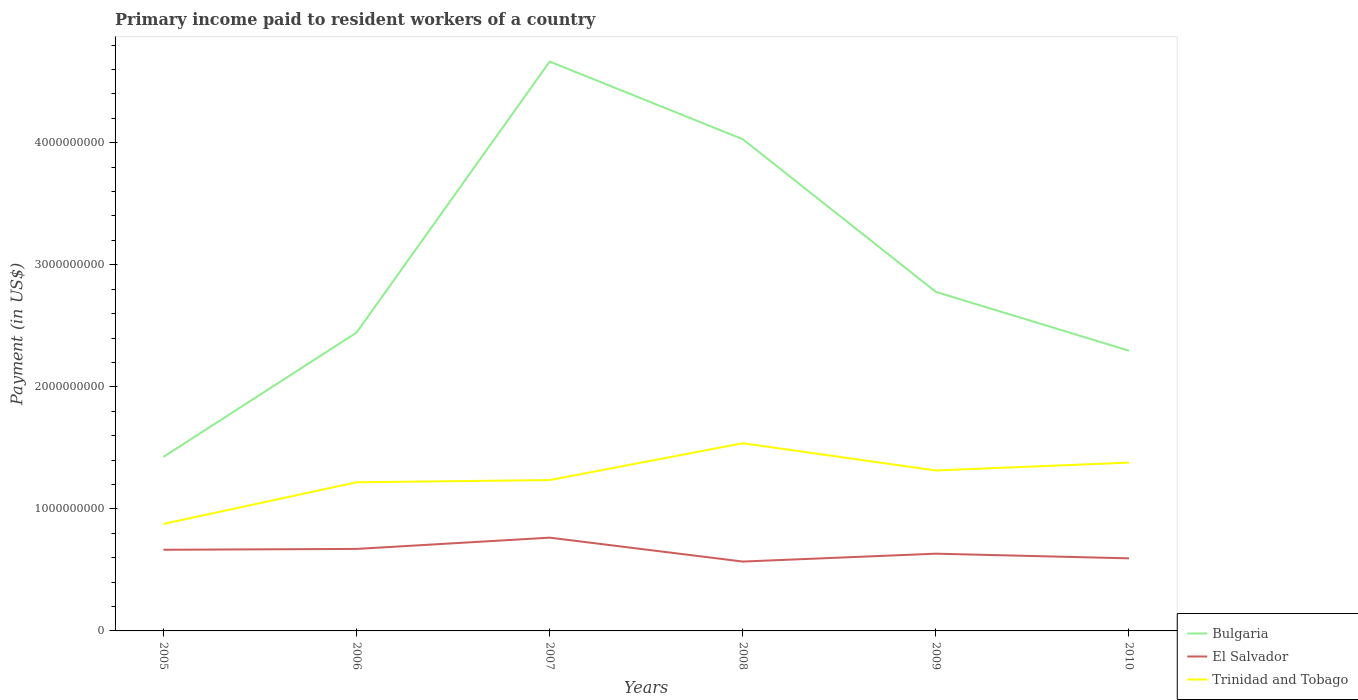Is the number of lines equal to the number of legend labels?
Provide a short and direct response. Yes. Across all years, what is the maximum amount paid to workers in Bulgaria?
Your answer should be compact. 1.43e+09. In which year was the amount paid to workers in El Salvador maximum?
Offer a very short reply. 2008. What is the total amount paid to workers in Trinidad and Tobago in the graph?
Your answer should be very brief. -1.61e+08. What is the difference between the highest and the second highest amount paid to workers in El Salvador?
Offer a very short reply. 1.96e+08. Is the amount paid to workers in Trinidad and Tobago strictly greater than the amount paid to workers in El Salvador over the years?
Make the answer very short. No. How many lines are there?
Offer a very short reply. 3. How many years are there in the graph?
Your response must be concise. 6. What is the difference between two consecutive major ticks on the Y-axis?
Make the answer very short. 1.00e+09. Are the values on the major ticks of Y-axis written in scientific E-notation?
Offer a very short reply. No. Does the graph contain any zero values?
Your answer should be compact. No. Where does the legend appear in the graph?
Your response must be concise. Bottom right. How are the legend labels stacked?
Your response must be concise. Vertical. What is the title of the graph?
Keep it short and to the point. Primary income paid to resident workers of a country. What is the label or title of the X-axis?
Provide a short and direct response. Years. What is the label or title of the Y-axis?
Make the answer very short. Payment (in US$). What is the Payment (in US$) of Bulgaria in 2005?
Offer a terse response. 1.43e+09. What is the Payment (in US$) of El Salvador in 2005?
Give a very brief answer. 6.65e+08. What is the Payment (in US$) of Trinidad and Tobago in 2005?
Provide a succinct answer. 8.77e+08. What is the Payment (in US$) of Bulgaria in 2006?
Ensure brevity in your answer.  2.44e+09. What is the Payment (in US$) of El Salvador in 2006?
Give a very brief answer. 6.72e+08. What is the Payment (in US$) of Trinidad and Tobago in 2006?
Keep it short and to the point. 1.22e+09. What is the Payment (in US$) in Bulgaria in 2007?
Make the answer very short. 4.67e+09. What is the Payment (in US$) of El Salvador in 2007?
Provide a short and direct response. 7.64e+08. What is the Payment (in US$) in Trinidad and Tobago in 2007?
Give a very brief answer. 1.24e+09. What is the Payment (in US$) of Bulgaria in 2008?
Offer a terse response. 4.03e+09. What is the Payment (in US$) in El Salvador in 2008?
Make the answer very short. 5.68e+08. What is the Payment (in US$) of Trinidad and Tobago in 2008?
Your answer should be compact. 1.54e+09. What is the Payment (in US$) in Bulgaria in 2009?
Your answer should be very brief. 2.78e+09. What is the Payment (in US$) of El Salvador in 2009?
Offer a very short reply. 6.33e+08. What is the Payment (in US$) in Trinidad and Tobago in 2009?
Your answer should be compact. 1.31e+09. What is the Payment (in US$) in Bulgaria in 2010?
Your answer should be compact. 2.30e+09. What is the Payment (in US$) of El Salvador in 2010?
Give a very brief answer. 5.95e+08. What is the Payment (in US$) of Trinidad and Tobago in 2010?
Make the answer very short. 1.38e+09. Across all years, what is the maximum Payment (in US$) in Bulgaria?
Your response must be concise. 4.67e+09. Across all years, what is the maximum Payment (in US$) in El Salvador?
Make the answer very short. 7.64e+08. Across all years, what is the maximum Payment (in US$) in Trinidad and Tobago?
Your answer should be compact. 1.54e+09. Across all years, what is the minimum Payment (in US$) in Bulgaria?
Your answer should be compact. 1.43e+09. Across all years, what is the minimum Payment (in US$) of El Salvador?
Offer a very short reply. 5.68e+08. Across all years, what is the minimum Payment (in US$) in Trinidad and Tobago?
Provide a short and direct response. 8.77e+08. What is the total Payment (in US$) of Bulgaria in the graph?
Give a very brief answer. 1.76e+1. What is the total Payment (in US$) in El Salvador in the graph?
Provide a short and direct response. 3.90e+09. What is the total Payment (in US$) in Trinidad and Tobago in the graph?
Offer a terse response. 7.56e+09. What is the difference between the Payment (in US$) of Bulgaria in 2005 and that in 2006?
Ensure brevity in your answer.  -1.02e+09. What is the difference between the Payment (in US$) of El Salvador in 2005 and that in 2006?
Your response must be concise. -6.92e+06. What is the difference between the Payment (in US$) of Trinidad and Tobago in 2005 and that in 2006?
Your answer should be very brief. -3.41e+08. What is the difference between the Payment (in US$) of Bulgaria in 2005 and that in 2007?
Make the answer very short. -3.24e+09. What is the difference between the Payment (in US$) of El Salvador in 2005 and that in 2007?
Offer a terse response. -9.93e+07. What is the difference between the Payment (in US$) in Trinidad and Tobago in 2005 and that in 2007?
Ensure brevity in your answer.  -3.59e+08. What is the difference between the Payment (in US$) of Bulgaria in 2005 and that in 2008?
Provide a short and direct response. -2.60e+09. What is the difference between the Payment (in US$) of El Salvador in 2005 and that in 2008?
Provide a succinct answer. 9.67e+07. What is the difference between the Payment (in US$) in Trinidad and Tobago in 2005 and that in 2008?
Offer a terse response. -6.61e+08. What is the difference between the Payment (in US$) in Bulgaria in 2005 and that in 2009?
Provide a succinct answer. -1.35e+09. What is the difference between the Payment (in US$) in El Salvador in 2005 and that in 2009?
Offer a terse response. 3.21e+07. What is the difference between the Payment (in US$) of Trinidad and Tobago in 2005 and that in 2009?
Your answer should be compact. -4.38e+08. What is the difference between the Payment (in US$) in Bulgaria in 2005 and that in 2010?
Give a very brief answer. -8.70e+08. What is the difference between the Payment (in US$) of El Salvador in 2005 and that in 2010?
Ensure brevity in your answer.  7.03e+07. What is the difference between the Payment (in US$) in Trinidad and Tobago in 2005 and that in 2010?
Provide a short and direct response. -5.02e+08. What is the difference between the Payment (in US$) in Bulgaria in 2006 and that in 2007?
Provide a short and direct response. -2.22e+09. What is the difference between the Payment (in US$) in El Salvador in 2006 and that in 2007?
Offer a terse response. -9.24e+07. What is the difference between the Payment (in US$) in Trinidad and Tobago in 2006 and that in 2007?
Your answer should be very brief. -1.78e+07. What is the difference between the Payment (in US$) in Bulgaria in 2006 and that in 2008?
Your response must be concise. -1.58e+09. What is the difference between the Payment (in US$) in El Salvador in 2006 and that in 2008?
Ensure brevity in your answer.  1.04e+08. What is the difference between the Payment (in US$) in Trinidad and Tobago in 2006 and that in 2008?
Make the answer very short. -3.20e+08. What is the difference between the Payment (in US$) of Bulgaria in 2006 and that in 2009?
Make the answer very short. -3.33e+08. What is the difference between the Payment (in US$) in El Salvador in 2006 and that in 2009?
Offer a very short reply. 3.90e+07. What is the difference between the Payment (in US$) in Trinidad and Tobago in 2006 and that in 2009?
Your response must be concise. -9.66e+07. What is the difference between the Payment (in US$) of Bulgaria in 2006 and that in 2010?
Make the answer very short. 1.49e+08. What is the difference between the Payment (in US$) in El Salvador in 2006 and that in 2010?
Ensure brevity in your answer.  7.72e+07. What is the difference between the Payment (in US$) of Trinidad and Tobago in 2006 and that in 2010?
Ensure brevity in your answer.  -1.61e+08. What is the difference between the Payment (in US$) of Bulgaria in 2007 and that in 2008?
Your answer should be very brief. 6.36e+08. What is the difference between the Payment (in US$) of El Salvador in 2007 and that in 2008?
Give a very brief answer. 1.96e+08. What is the difference between the Payment (in US$) of Trinidad and Tobago in 2007 and that in 2008?
Offer a very short reply. -3.02e+08. What is the difference between the Payment (in US$) in Bulgaria in 2007 and that in 2009?
Ensure brevity in your answer.  1.89e+09. What is the difference between the Payment (in US$) of El Salvador in 2007 and that in 2009?
Your answer should be compact. 1.31e+08. What is the difference between the Payment (in US$) in Trinidad and Tobago in 2007 and that in 2009?
Offer a very short reply. -7.88e+07. What is the difference between the Payment (in US$) in Bulgaria in 2007 and that in 2010?
Keep it short and to the point. 2.37e+09. What is the difference between the Payment (in US$) of El Salvador in 2007 and that in 2010?
Offer a terse response. 1.70e+08. What is the difference between the Payment (in US$) in Trinidad and Tobago in 2007 and that in 2010?
Provide a succinct answer. -1.43e+08. What is the difference between the Payment (in US$) in Bulgaria in 2008 and that in 2009?
Keep it short and to the point. 1.25e+09. What is the difference between the Payment (in US$) of El Salvador in 2008 and that in 2009?
Make the answer very short. -6.46e+07. What is the difference between the Payment (in US$) in Trinidad and Tobago in 2008 and that in 2009?
Your answer should be very brief. 2.23e+08. What is the difference between the Payment (in US$) of Bulgaria in 2008 and that in 2010?
Provide a short and direct response. 1.73e+09. What is the difference between the Payment (in US$) in El Salvador in 2008 and that in 2010?
Offer a very short reply. -2.64e+07. What is the difference between the Payment (in US$) in Trinidad and Tobago in 2008 and that in 2010?
Offer a terse response. 1.59e+08. What is the difference between the Payment (in US$) in Bulgaria in 2009 and that in 2010?
Ensure brevity in your answer.  4.82e+08. What is the difference between the Payment (in US$) in El Salvador in 2009 and that in 2010?
Keep it short and to the point. 3.82e+07. What is the difference between the Payment (in US$) in Trinidad and Tobago in 2009 and that in 2010?
Provide a short and direct response. -6.45e+07. What is the difference between the Payment (in US$) in Bulgaria in 2005 and the Payment (in US$) in El Salvador in 2006?
Your answer should be very brief. 7.54e+08. What is the difference between the Payment (in US$) in Bulgaria in 2005 and the Payment (in US$) in Trinidad and Tobago in 2006?
Give a very brief answer. 2.08e+08. What is the difference between the Payment (in US$) of El Salvador in 2005 and the Payment (in US$) of Trinidad and Tobago in 2006?
Your answer should be compact. -5.53e+08. What is the difference between the Payment (in US$) in Bulgaria in 2005 and the Payment (in US$) in El Salvador in 2007?
Make the answer very short. 6.62e+08. What is the difference between the Payment (in US$) of Bulgaria in 2005 and the Payment (in US$) of Trinidad and Tobago in 2007?
Your answer should be compact. 1.90e+08. What is the difference between the Payment (in US$) in El Salvador in 2005 and the Payment (in US$) in Trinidad and Tobago in 2007?
Make the answer very short. -5.71e+08. What is the difference between the Payment (in US$) in Bulgaria in 2005 and the Payment (in US$) in El Salvador in 2008?
Your response must be concise. 8.58e+08. What is the difference between the Payment (in US$) of Bulgaria in 2005 and the Payment (in US$) of Trinidad and Tobago in 2008?
Offer a terse response. -1.12e+08. What is the difference between the Payment (in US$) of El Salvador in 2005 and the Payment (in US$) of Trinidad and Tobago in 2008?
Give a very brief answer. -8.73e+08. What is the difference between the Payment (in US$) of Bulgaria in 2005 and the Payment (in US$) of El Salvador in 2009?
Keep it short and to the point. 7.93e+08. What is the difference between the Payment (in US$) in Bulgaria in 2005 and the Payment (in US$) in Trinidad and Tobago in 2009?
Provide a succinct answer. 1.11e+08. What is the difference between the Payment (in US$) of El Salvador in 2005 and the Payment (in US$) of Trinidad and Tobago in 2009?
Your answer should be very brief. -6.50e+08. What is the difference between the Payment (in US$) in Bulgaria in 2005 and the Payment (in US$) in El Salvador in 2010?
Provide a short and direct response. 8.31e+08. What is the difference between the Payment (in US$) in Bulgaria in 2005 and the Payment (in US$) in Trinidad and Tobago in 2010?
Give a very brief answer. 4.68e+07. What is the difference between the Payment (in US$) in El Salvador in 2005 and the Payment (in US$) in Trinidad and Tobago in 2010?
Provide a succinct answer. -7.14e+08. What is the difference between the Payment (in US$) of Bulgaria in 2006 and the Payment (in US$) of El Salvador in 2007?
Your answer should be compact. 1.68e+09. What is the difference between the Payment (in US$) in Bulgaria in 2006 and the Payment (in US$) in Trinidad and Tobago in 2007?
Offer a terse response. 1.21e+09. What is the difference between the Payment (in US$) of El Salvador in 2006 and the Payment (in US$) of Trinidad and Tobago in 2007?
Keep it short and to the point. -5.64e+08. What is the difference between the Payment (in US$) in Bulgaria in 2006 and the Payment (in US$) in El Salvador in 2008?
Keep it short and to the point. 1.88e+09. What is the difference between the Payment (in US$) of Bulgaria in 2006 and the Payment (in US$) of Trinidad and Tobago in 2008?
Your answer should be compact. 9.07e+08. What is the difference between the Payment (in US$) of El Salvador in 2006 and the Payment (in US$) of Trinidad and Tobago in 2008?
Keep it short and to the point. -8.66e+08. What is the difference between the Payment (in US$) in Bulgaria in 2006 and the Payment (in US$) in El Salvador in 2009?
Your answer should be very brief. 1.81e+09. What is the difference between the Payment (in US$) of Bulgaria in 2006 and the Payment (in US$) of Trinidad and Tobago in 2009?
Your answer should be very brief. 1.13e+09. What is the difference between the Payment (in US$) of El Salvador in 2006 and the Payment (in US$) of Trinidad and Tobago in 2009?
Ensure brevity in your answer.  -6.43e+08. What is the difference between the Payment (in US$) of Bulgaria in 2006 and the Payment (in US$) of El Salvador in 2010?
Give a very brief answer. 1.85e+09. What is the difference between the Payment (in US$) in Bulgaria in 2006 and the Payment (in US$) in Trinidad and Tobago in 2010?
Provide a short and direct response. 1.07e+09. What is the difference between the Payment (in US$) of El Salvador in 2006 and the Payment (in US$) of Trinidad and Tobago in 2010?
Give a very brief answer. -7.07e+08. What is the difference between the Payment (in US$) in Bulgaria in 2007 and the Payment (in US$) in El Salvador in 2008?
Keep it short and to the point. 4.10e+09. What is the difference between the Payment (in US$) of Bulgaria in 2007 and the Payment (in US$) of Trinidad and Tobago in 2008?
Give a very brief answer. 3.13e+09. What is the difference between the Payment (in US$) of El Salvador in 2007 and the Payment (in US$) of Trinidad and Tobago in 2008?
Your answer should be compact. -7.74e+08. What is the difference between the Payment (in US$) of Bulgaria in 2007 and the Payment (in US$) of El Salvador in 2009?
Provide a succinct answer. 4.03e+09. What is the difference between the Payment (in US$) in Bulgaria in 2007 and the Payment (in US$) in Trinidad and Tobago in 2009?
Provide a short and direct response. 3.35e+09. What is the difference between the Payment (in US$) of El Salvador in 2007 and the Payment (in US$) of Trinidad and Tobago in 2009?
Your answer should be compact. -5.50e+08. What is the difference between the Payment (in US$) in Bulgaria in 2007 and the Payment (in US$) in El Salvador in 2010?
Offer a very short reply. 4.07e+09. What is the difference between the Payment (in US$) of Bulgaria in 2007 and the Payment (in US$) of Trinidad and Tobago in 2010?
Make the answer very short. 3.29e+09. What is the difference between the Payment (in US$) in El Salvador in 2007 and the Payment (in US$) in Trinidad and Tobago in 2010?
Make the answer very short. -6.15e+08. What is the difference between the Payment (in US$) of Bulgaria in 2008 and the Payment (in US$) of El Salvador in 2009?
Give a very brief answer. 3.40e+09. What is the difference between the Payment (in US$) in Bulgaria in 2008 and the Payment (in US$) in Trinidad and Tobago in 2009?
Provide a short and direct response. 2.71e+09. What is the difference between the Payment (in US$) in El Salvador in 2008 and the Payment (in US$) in Trinidad and Tobago in 2009?
Offer a terse response. -7.46e+08. What is the difference between the Payment (in US$) of Bulgaria in 2008 and the Payment (in US$) of El Salvador in 2010?
Provide a succinct answer. 3.43e+09. What is the difference between the Payment (in US$) in Bulgaria in 2008 and the Payment (in US$) in Trinidad and Tobago in 2010?
Your answer should be compact. 2.65e+09. What is the difference between the Payment (in US$) of El Salvador in 2008 and the Payment (in US$) of Trinidad and Tobago in 2010?
Offer a very short reply. -8.11e+08. What is the difference between the Payment (in US$) in Bulgaria in 2009 and the Payment (in US$) in El Salvador in 2010?
Give a very brief answer. 2.18e+09. What is the difference between the Payment (in US$) of Bulgaria in 2009 and the Payment (in US$) of Trinidad and Tobago in 2010?
Ensure brevity in your answer.  1.40e+09. What is the difference between the Payment (in US$) in El Salvador in 2009 and the Payment (in US$) in Trinidad and Tobago in 2010?
Your answer should be very brief. -7.46e+08. What is the average Payment (in US$) in Bulgaria per year?
Offer a very short reply. 2.94e+09. What is the average Payment (in US$) of El Salvador per year?
Provide a succinct answer. 6.50e+08. What is the average Payment (in US$) in Trinidad and Tobago per year?
Give a very brief answer. 1.26e+09. In the year 2005, what is the difference between the Payment (in US$) in Bulgaria and Payment (in US$) in El Salvador?
Give a very brief answer. 7.61e+08. In the year 2005, what is the difference between the Payment (in US$) of Bulgaria and Payment (in US$) of Trinidad and Tobago?
Your answer should be very brief. 5.49e+08. In the year 2005, what is the difference between the Payment (in US$) of El Salvador and Payment (in US$) of Trinidad and Tobago?
Your answer should be very brief. -2.12e+08. In the year 2006, what is the difference between the Payment (in US$) in Bulgaria and Payment (in US$) in El Salvador?
Make the answer very short. 1.77e+09. In the year 2006, what is the difference between the Payment (in US$) in Bulgaria and Payment (in US$) in Trinidad and Tobago?
Give a very brief answer. 1.23e+09. In the year 2006, what is the difference between the Payment (in US$) of El Salvador and Payment (in US$) of Trinidad and Tobago?
Ensure brevity in your answer.  -5.46e+08. In the year 2007, what is the difference between the Payment (in US$) of Bulgaria and Payment (in US$) of El Salvador?
Provide a short and direct response. 3.90e+09. In the year 2007, what is the difference between the Payment (in US$) in Bulgaria and Payment (in US$) in Trinidad and Tobago?
Your answer should be compact. 3.43e+09. In the year 2007, what is the difference between the Payment (in US$) in El Salvador and Payment (in US$) in Trinidad and Tobago?
Offer a very short reply. -4.72e+08. In the year 2008, what is the difference between the Payment (in US$) of Bulgaria and Payment (in US$) of El Salvador?
Make the answer very short. 3.46e+09. In the year 2008, what is the difference between the Payment (in US$) of Bulgaria and Payment (in US$) of Trinidad and Tobago?
Your answer should be compact. 2.49e+09. In the year 2008, what is the difference between the Payment (in US$) in El Salvador and Payment (in US$) in Trinidad and Tobago?
Your response must be concise. -9.70e+08. In the year 2009, what is the difference between the Payment (in US$) in Bulgaria and Payment (in US$) in El Salvador?
Offer a very short reply. 2.15e+09. In the year 2009, what is the difference between the Payment (in US$) in Bulgaria and Payment (in US$) in Trinidad and Tobago?
Make the answer very short. 1.46e+09. In the year 2009, what is the difference between the Payment (in US$) of El Salvador and Payment (in US$) of Trinidad and Tobago?
Provide a succinct answer. -6.82e+08. In the year 2010, what is the difference between the Payment (in US$) in Bulgaria and Payment (in US$) in El Salvador?
Your answer should be very brief. 1.70e+09. In the year 2010, what is the difference between the Payment (in US$) in Bulgaria and Payment (in US$) in Trinidad and Tobago?
Offer a terse response. 9.17e+08. In the year 2010, what is the difference between the Payment (in US$) in El Salvador and Payment (in US$) in Trinidad and Tobago?
Your response must be concise. -7.84e+08. What is the ratio of the Payment (in US$) in Bulgaria in 2005 to that in 2006?
Ensure brevity in your answer.  0.58. What is the ratio of the Payment (in US$) in El Salvador in 2005 to that in 2006?
Keep it short and to the point. 0.99. What is the ratio of the Payment (in US$) in Trinidad and Tobago in 2005 to that in 2006?
Make the answer very short. 0.72. What is the ratio of the Payment (in US$) in Bulgaria in 2005 to that in 2007?
Make the answer very short. 0.31. What is the ratio of the Payment (in US$) of El Salvador in 2005 to that in 2007?
Provide a succinct answer. 0.87. What is the ratio of the Payment (in US$) in Trinidad and Tobago in 2005 to that in 2007?
Offer a terse response. 0.71. What is the ratio of the Payment (in US$) of Bulgaria in 2005 to that in 2008?
Give a very brief answer. 0.35. What is the ratio of the Payment (in US$) in El Salvador in 2005 to that in 2008?
Your answer should be very brief. 1.17. What is the ratio of the Payment (in US$) of Trinidad and Tobago in 2005 to that in 2008?
Provide a short and direct response. 0.57. What is the ratio of the Payment (in US$) in Bulgaria in 2005 to that in 2009?
Offer a very short reply. 0.51. What is the ratio of the Payment (in US$) of El Salvador in 2005 to that in 2009?
Make the answer very short. 1.05. What is the ratio of the Payment (in US$) of Trinidad and Tobago in 2005 to that in 2009?
Make the answer very short. 0.67. What is the ratio of the Payment (in US$) in Bulgaria in 2005 to that in 2010?
Your response must be concise. 0.62. What is the ratio of the Payment (in US$) of El Salvador in 2005 to that in 2010?
Provide a succinct answer. 1.12. What is the ratio of the Payment (in US$) in Trinidad and Tobago in 2005 to that in 2010?
Offer a very short reply. 0.64. What is the ratio of the Payment (in US$) of Bulgaria in 2006 to that in 2007?
Offer a terse response. 0.52. What is the ratio of the Payment (in US$) of El Salvador in 2006 to that in 2007?
Provide a succinct answer. 0.88. What is the ratio of the Payment (in US$) in Trinidad and Tobago in 2006 to that in 2007?
Your answer should be compact. 0.99. What is the ratio of the Payment (in US$) of Bulgaria in 2006 to that in 2008?
Offer a terse response. 0.61. What is the ratio of the Payment (in US$) in El Salvador in 2006 to that in 2008?
Give a very brief answer. 1.18. What is the ratio of the Payment (in US$) of Trinidad and Tobago in 2006 to that in 2008?
Give a very brief answer. 0.79. What is the ratio of the Payment (in US$) in Bulgaria in 2006 to that in 2009?
Provide a succinct answer. 0.88. What is the ratio of the Payment (in US$) of El Salvador in 2006 to that in 2009?
Your response must be concise. 1.06. What is the ratio of the Payment (in US$) in Trinidad and Tobago in 2006 to that in 2009?
Your response must be concise. 0.93. What is the ratio of the Payment (in US$) of Bulgaria in 2006 to that in 2010?
Keep it short and to the point. 1.06. What is the ratio of the Payment (in US$) in El Salvador in 2006 to that in 2010?
Your answer should be very brief. 1.13. What is the ratio of the Payment (in US$) of Trinidad and Tobago in 2006 to that in 2010?
Offer a terse response. 0.88. What is the ratio of the Payment (in US$) in Bulgaria in 2007 to that in 2008?
Keep it short and to the point. 1.16. What is the ratio of the Payment (in US$) of El Salvador in 2007 to that in 2008?
Offer a very short reply. 1.34. What is the ratio of the Payment (in US$) of Trinidad and Tobago in 2007 to that in 2008?
Your answer should be very brief. 0.8. What is the ratio of the Payment (in US$) of Bulgaria in 2007 to that in 2009?
Your answer should be compact. 1.68. What is the ratio of the Payment (in US$) in El Salvador in 2007 to that in 2009?
Provide a short and direct response. 1.21. What is the ratio of the Payment (in US$) in Trinidad and Tobago in 2007 to that in 2009?
Provide a succinct answer. 0.94. What is the ratio of the Payment (in US$) of Bulgaria in 2007 to that in 2010?
Provide a succinct answer. 2.03. What is the ratio of the Payment (in US$) of El Salvador in 2007 to that in 2010?
Keep it short and to the point. 1.29. What is the ratio of the Payment (in US$) in Trinidad and Tobago in 2007 to that in 2010?
Make the answer very short. 0.9. What is the ratio of the Payment (in US$) in Bulgaria in 2008 to that in 2009?
Give a very brief answer. 1.45. What is the ratio of the Payment (in US$) in El Salvador in 2008 to that in 2009?
Give a very brief answer. 0.9. What is the ratio of the Payment (in US$) of Trinidad and Tobago in 2008 to that in 2009?
Give a very brief answer. 1.17. What is the ratio of the Payment (in US$) of Bulgaria in 2008 to that in 2010?
Offer a very short reply. 1.75. What is the ratio of the Payment (in US$) of El Salvador in 2008 to that in 2010?
Ensure brevity in your answer.  0.96. What is the ratio of the Payment (in US$) in Trinidad and Tobago in 2008 to that in 2010?
Make the answer very short. 1.12. What is the ratio of the Payment (in US$) of Bulgaria in 2009 to that in 2010?
Offer a terse response. 1.21. What is the ratio of the Payment (in US$) of El Salvador in 2009 to that in 2010?
Make the answer very short. 1.06. What is the ratio of the Payment (in US$) of Trinidad and Tobago in 2009 to that in 2010?
Offer a very short reply. 0.95. What is the difference between the highest and the second highest Payment (in US$) of Bulgaria?
Your response must be concise. 6.36e+08. What is the difference between the highest and the second highest Payment (in US$) of El Salvador?
Offer a terse response. 9.24e+07. What is the difference between the highest and the second highest Payment (in US$) of Trinidad and Tobago?
Your response must be concise. 1.59e+08. What is the difference between the highest and the lowest Payment (in US$) in Bulgaria?
Offer a terse response. 3.24e+09. What is the difference between the highest and the lowest Payment (in US$) of El Salvador?
Provide a short and direct response. 1.96e+08. What is the difference between the highest and the lowest Payment (in US$) in Trinidad and Tobago?
Give a very brief answer. 6.61e+08. 